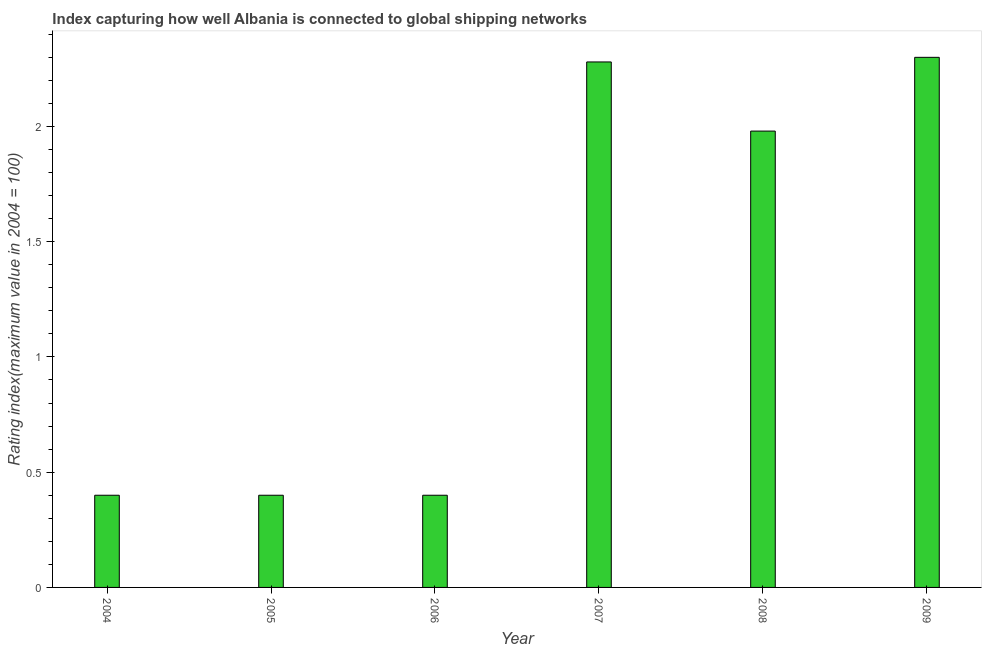Does the graph contain grids?
Your response must be concise. No. What is the title of the graph?
Provide a succinct answer. Index capturing how well Albania is connected to global shipping networks. What is the label or title of the Y-axis?
Offer a very short reply. Rating index(maximum value in 2004 = 100). What is the liner shipping connectivity index in 2008?
Provide a short and direct response. 1.98. Across all years, what is the maximum liner shipping connectivity index?
Give a very brief answer. 2.3. In which year was the liner shipping connectivity index maximum?
Your response must be concise. 2009. What is the sum of the liner shipping connectivity index?
Ensure brevity in your answer.  7.76. What is the difference between the liner shipping connectivity index in 2006 and 2007?
Keep it short and to the point. -1.88. What is the average liner shipping connectivity index per year?
Offer a very short reply. 1.29. What is the median liner shipping connectivity index?
Keep it short and to the point. 1.19. In how many years, is the liner shipping connectivity index greater than 0.1 ?
Ensure brevity in your answer.  6. What is the ratio of the liner shipping connectivity index in 2004 to that in 2008?
Offer a very short reply. 0.2. Is the sum of the liner shipping connectivity index in 2006 and 2009 greater than the maximum liner shipping connectivity index across all years?
Provide a succinct answer. Yes. What is the difference between the highest and the lowest liner shipping connectivity index?
Offer a terse response. 1.9. In how many years, is the liner shipping connectivity index greater than the average liner shipping connectivity index taken over all years?
Your answer should be compact. 3. How many bars are there?
Ensure brevity in your answer.  6. Are all the bars in the graph horizontal?
Keep it short and to the point. No. What is the Rating index(maximum value in 2004 = 100) in 2006?
Ensure brevity in your answer.  0.4. What is the Rating index(maximum value in 2004 = 100) in 2007?
Your answer should be very brief. 2.28. What is the Rating index(maximum value in 2004 = 100) of 2008?
Make the answer very short. 1.98. What is the difference between the Rating index(maximum value in 2004 = 100) in 2004 and 2006?
Ensure brevity in your answer.  0. What is the difference between the Rating index(maximum value in 2004 = 100) in 2004 and 2007?
Make the answer very short. -1.88. What is the difference between the Rating index(maximum value in 2004 = 100) in 2004 and 2008?
Your answer should be very brief. -1.58. What is the difference between the Rating index(maximum value in 2004 = 100) in 2005 and 2007?
Offer a terse response. -1.88. What is the difference between the Rating index(maximum value in 2004 = 100) in 2005 and 2008?
Your answer should be very brief. -1.58. What is the difference between the Rating index(maximum value in 2004 = 100) in 2005 and 2009?
Make the answer very short. -1.9. What is the difference between the Rating index(maximum value in 2004 = 100) in 2006 and 2007?
Ensure brevity in your answer.  -1.88. What is the difference between the Rating index(maximum value in 2004 = 100) in 2006 and 2008?
Provide a short and direct response. -1.58. What is the difference between the Rating index(maximum value in 2004 = 100) in 2007 and 2008?
Provide a succinct answer. 0.3. What is the difference between the Rating index(maximum value in 2004 = 100) in 2007 and 2009?
Make the answer very short. -0.02. What is the difference between the Rating index(maximum value in 2004 = 100) in 2008 and 2009?
Ensure brevity in your answer.  -0.32. What is the ratio of the Rating index(maximum value in 2004 = 100) in 2004 to that in 2005?
Provide a succinct answer. 1. What is the ratio of the Rating index(maximum value in 2004 = 100) in 2004 to that in 2007?
Your answer should be compact. 0.17. What is the ratio of the Rating index(maximum value in 2004 = 100) in 2004 to that in 2008?
Your answer should be compact. 0.2. What is the ratio of the Rating index(maximum value in 2004 = 100) in 2004 to that in 2009?
Ensure brevity in your answer.  0.17. What is the ratio of the Rating index(maximum value in 2004 = 100) in 2005 to that in 2007?
Your answer should be very brief. 0.17. What is the ratio of the Rating index(maximum value in 2004 = 100) in 2005 to that in 2008?
Your response must be concise. 0.2. What is the ratio of the Rating index(maximum value in 2004 = 100) in 2005 to that in 2009?
Your answer should be very brief. 0.17. What is the ratio of the Rating index(maximum value in 2004 = 100) in 2006 to that in 2007?
Make the answer very short. 0.17. What is the ratio of the Rating index(maximum value in 2004 = 100) in 2006 to that in 2008?
Keep it short and to the point. 0.2. What is the ratio of the Rating index(maximum value in 2004 = 100) in 2006 to that in 2009?
Your answer should be compact. 0.17. What is the ratio of the Rating index(maximum value in 2004 = 100) in 2007 to that in 2008?
Provide a succinct answer. 1.15. What is the ratio of the Rating index(maximum value in 2004 = 100) in 2008 to that in 2009?
Provide a short and direct response. 0.86. 